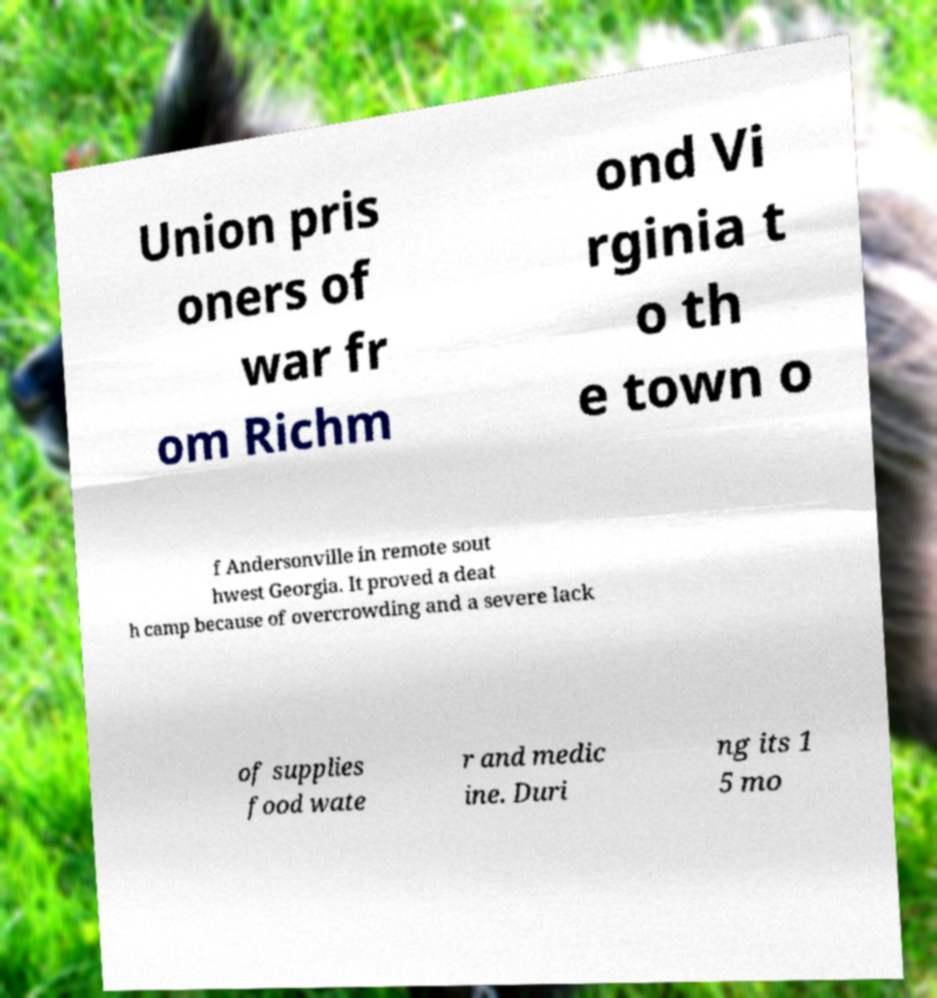Can you read and provide the text displayed in the image?This photo seems to have some interesting text. Can you extract and type it out for me? Union pris oners of war fr om Richm ond Vi rginia t o th e town o f Andersonville in remote sout hwest Georgia. It proved a deat h camp because of overcrowding and a severe lack of supplies food wate r and medic ine. Duri ng its 1 5 mo 